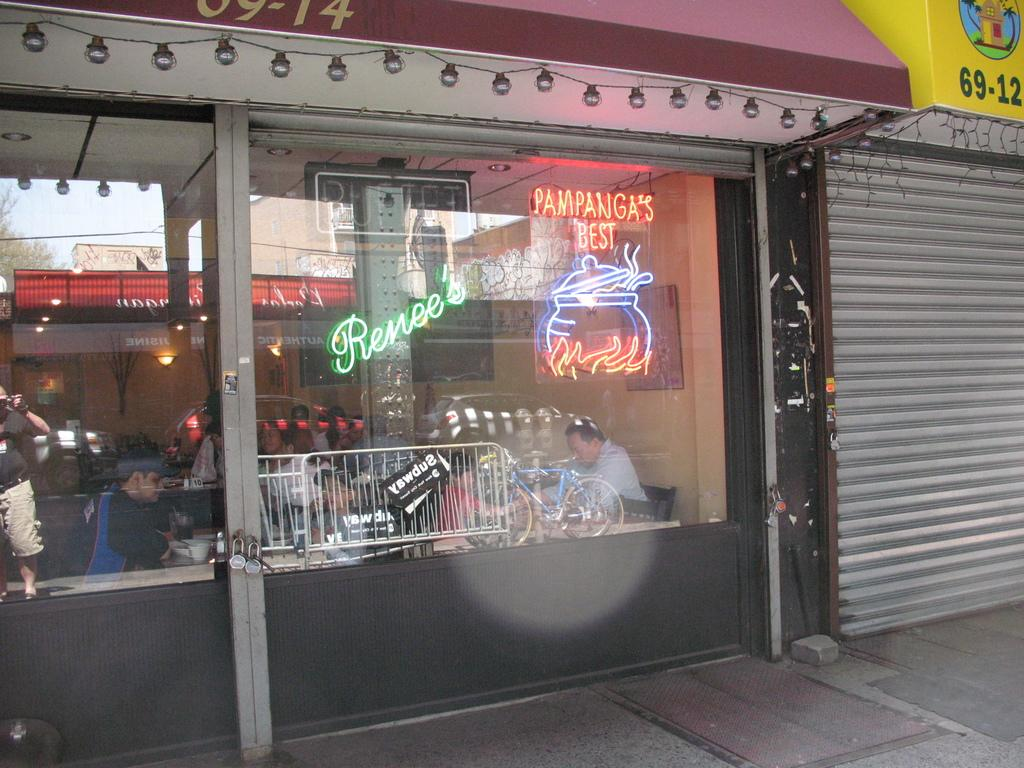What type of establishment is shown in the image? The image depicts a restaurant. Can you describe the people inside the restaurant? There are people sitting inside the restaurant. What is located next to the restaurant? There is a shop adjacent to the restaurant. What can be seen in terms of lighting in the image? There are lights visible in the image. What chess move is the brother making with his chin in the image? There is no chess game, brother, or chin movement present in the image. 